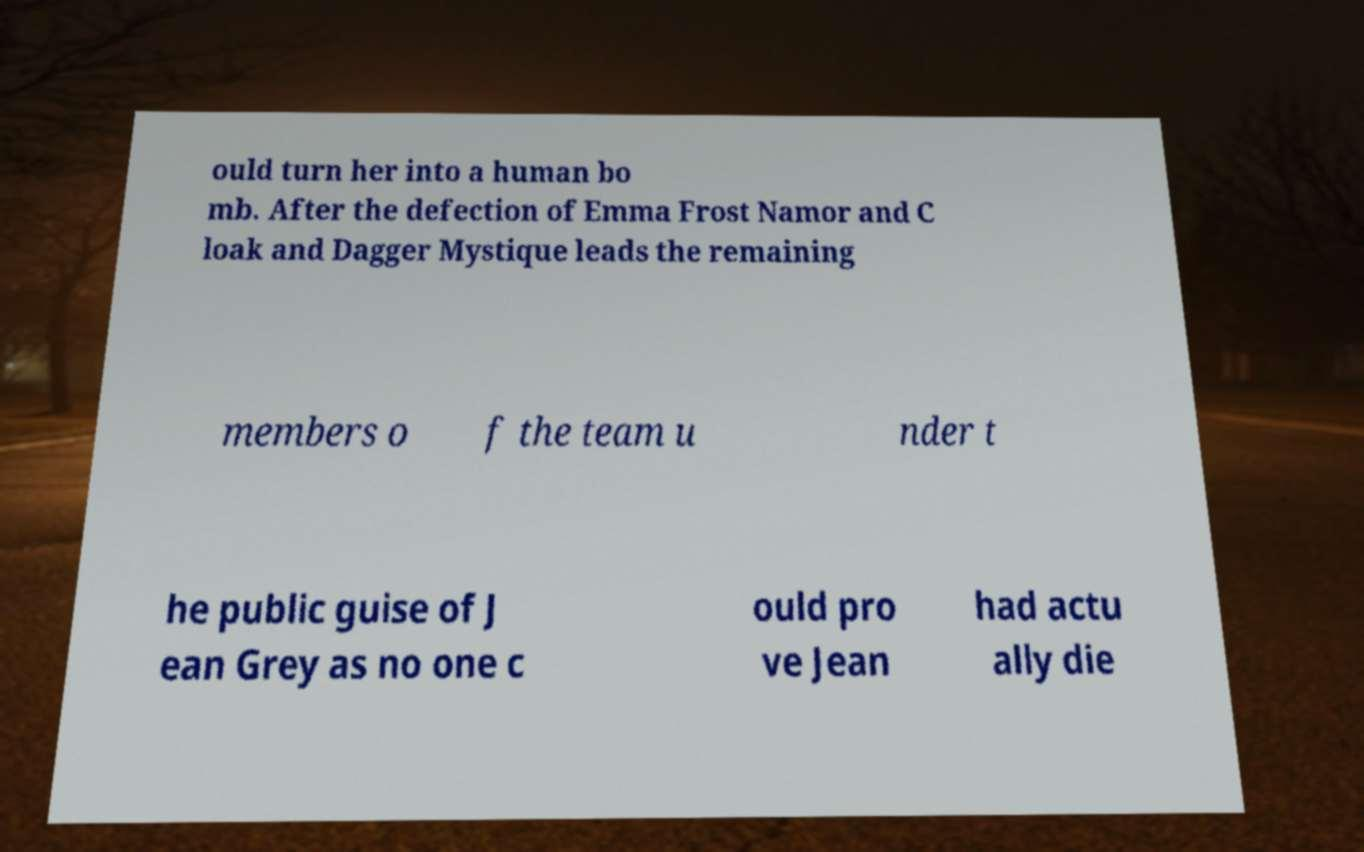There's text embedded in this image that I need extracted. Can you transcribe it verbatim? ould turn her into a human bo mb. After the defection of Emma Frost Namor and C loak and Dagger Mystique leads the remaining members o f the team u nder t he public guise of J ean Grey as no one c ould pro ve Jean had actu ally die 